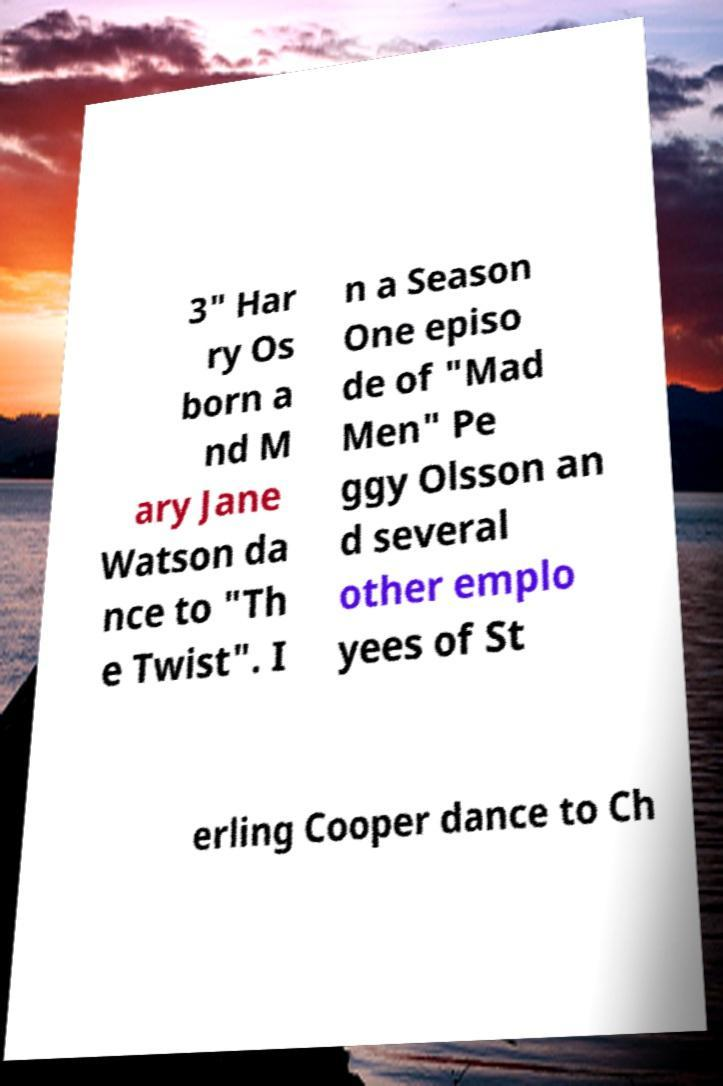I need the written content from this picture converted into text. Can you do that? 3" Har ry Os born a nd M ary Jane Watson da nce to "Th e Twist". I n a Season One episo de of "Mad Men" Pe ggy Olsson an d several other emplo yees of St erling Cooper dance to Ch 